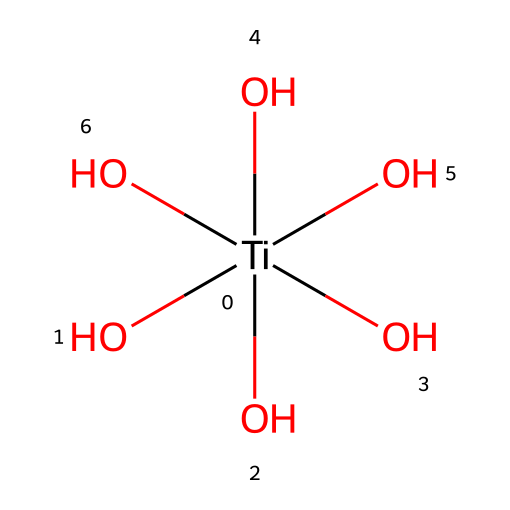What is the central metal atom in this coordination complex? The central metal atom can be identified from the SMILES representation. The '[Ti]' indicates the presence of titanium as the central atom in the coordination complex.
Answer: titanium How many hydroxyl groups are present in this chemical? By analyzing the SMILES notation, there are five instances of '(O)' following the '[Ti]' which indicates the presence of five hydroxyl groups.
Answer: five What type of bonding is primarily present in this coordination compound? The structure shows the coordination of hydroxyl groups directly bonded to the titanium. This suggests that the primary bonding type in this compound is coordination bonding.
Answer: coordination bonding What is the oxidation state of titanium in this complex? Titanium typically has an oxidation state of +4 in its coordination compounds, and since there are five hydroxyl groups (-1 each), the overall charge balance confirms titanium's +4 oxidation state.
Answer: +4 How does the presence of hydroxyl groups affect the properties of this compound? Hydroxyl groups enhance hydrophilicity in the compound, promoting water interaction, which is crucial for self-cleaning properties in architectural applications.
Answer: hydrophilicity Can you identify any potential applications of this coordination compound? The presence of titanium in a coordination complex with hydroxyl groups suggests applications in self-cleaning glass coatings, particularly in architecture, due to their photocatalytic properties.
Answer: self-cleaning glass coatings 